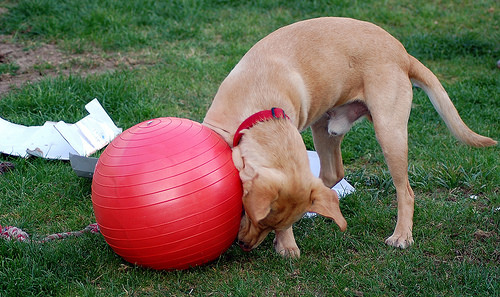<image>
Is there a ball on the dog? No. The ball is not positioned on the dog. They may be near each other, but the ball is not supported by or resting on top of the dog. Is there a ball next to the dog? Yes. The ball is positioned adjacent to the dog, located nearby in the same general area. 